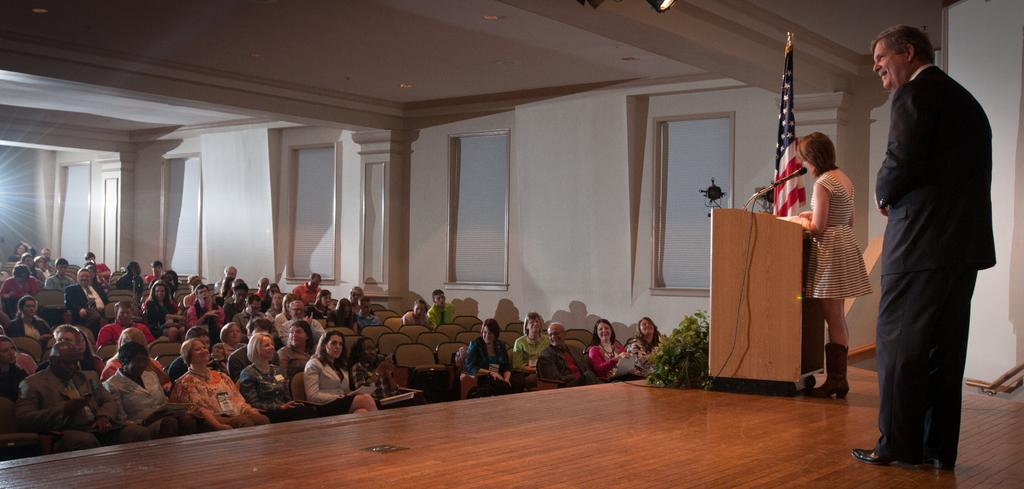What are the people in the image doing? There is a group of people sitting on chairs, and two people are standing on a stage. What can be seen on the stage? There is a podium, a microphone, and a flag on the stage. What is visible in the background of the image? There is a wall, windows, and a roof in the background. What else can be observed in the image? Lights are present in the image. Where is the basin located in the image? There is no basin present in the image. What type of neck accessory is worn by the person standing on the stage? The image does not provide information about any neck accessories worn by the people on stage. 